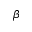<formula> <loc_0><loc_0><loc_500><loc_500>\beta</formula> 